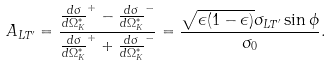<formula> <loc_0><loc_0><loc_500><loc_500>A _ { L T ^ { \prime } } = \frac { \frac { d \sigma } { d \Omega _ { K } ^ { * } } ^ { + } - \frac { d \sigma } { d \Omega _ { K } ^ { * } } ^ { - } } { \frac { d \sigma } { d \Omega _ { K } ^ { * } } ^ { + } + \frac { d \sigma } { d \Omega _ { K } ^ { * } } ^ { - } } = \frac { \sqrt { \epsilon ( 1 - \epsilon ) } \sigma _ { L T ^ { \prime } } \sin \phi } { \sigma _ { 0 } } .</formula> 